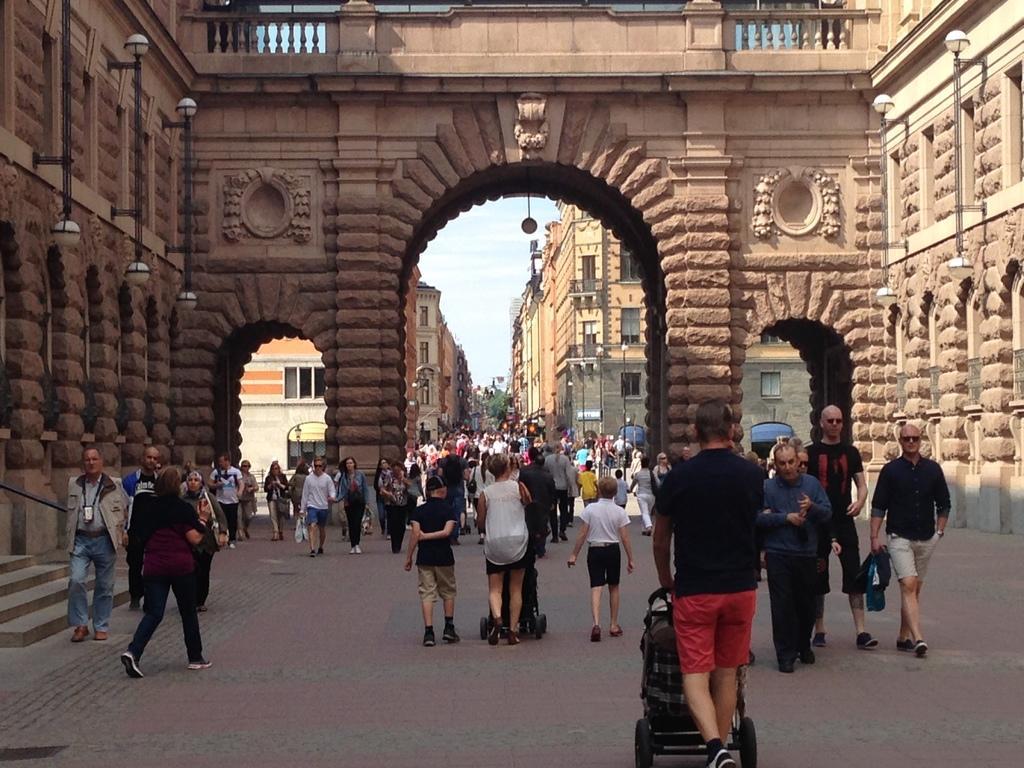Describe this image in one or two sentences. In this picture describe about a group of people with baby prams is walking in front of the image. Behind we can see a brown color brick roman arch. 